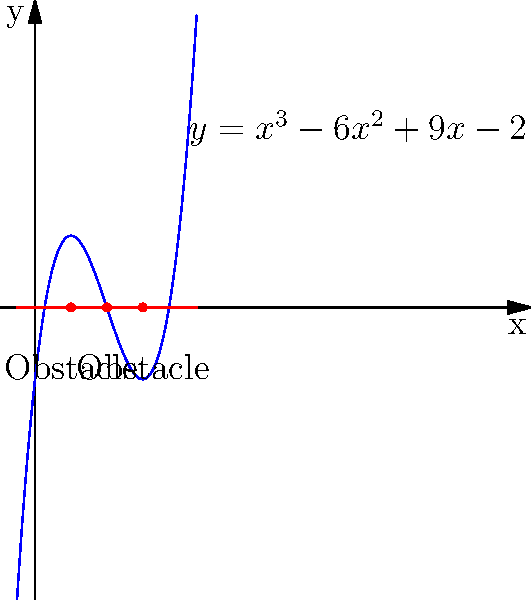As a guide dog trainer, you're designing an optimal path for a dog to navigate between obstacles. The path can be modeled by the polynomial function $f(x) = x^3 - 6x^2 + 9x - 2$, where the roots represent safe passage points between obstacles. Find all roots of this polynomial equation to determine the safe navigation points for the guide dog. To find the roots of the polynomial $f(x) = x^3 - 6x^2 + 9x - 2$, we need to solve the equation $f(x) = 0$. Let's approach this step-by-step:

1) First, let's check if there are any obvious factors:
   $f(1) = 1 - 6 + 9 - 2 = 2$, so 1 is not a root.
   $f(2) = 8 - 24 + 18 - 2 = 0$, so 2 is a root.

2) Since 2 is a root, $(x-2)$ is a factor of the polynomial. Let's divide $f(x)$ by $(x-2)$:

   $x^3 - 6x^2 + 9x - 2 = (x-2)(x^2 - 4x + 1)$

3) Now we need to solve $x^2 - 4x + 1 = 0$. This is a quadratic equation.

4) We can solve this using the quadratic formula: $x = \frac{-b \pm \sqrt{b^2 - 4ac}}{2a}$
   Where $a=1$, $b=-4$, and $c=1$

5) Plugging these values into the formula:
   $x = \frac{4 \pm \sqrt{16 - 4}}{2} = \frac{4 \pm \sqrt{12}}{2} = \frac{4 \pm 2\sqrt{3}}{2}$

6) Simplifying:
   $x = 2 \pm \sqrt{3}$

Therefore, the roots of the polynomial are:
$x = 2$ (from step 2)
$x = 2 + \sqrt{3}$ and $x = 2 - \sqrt{3}$ (from step 6)

These roots represent the safe navigation points for the guide dog between obstacles.
Answer: $x = 2, 2 + \sqrt{3}, 2 - \sqrt{3}$ 